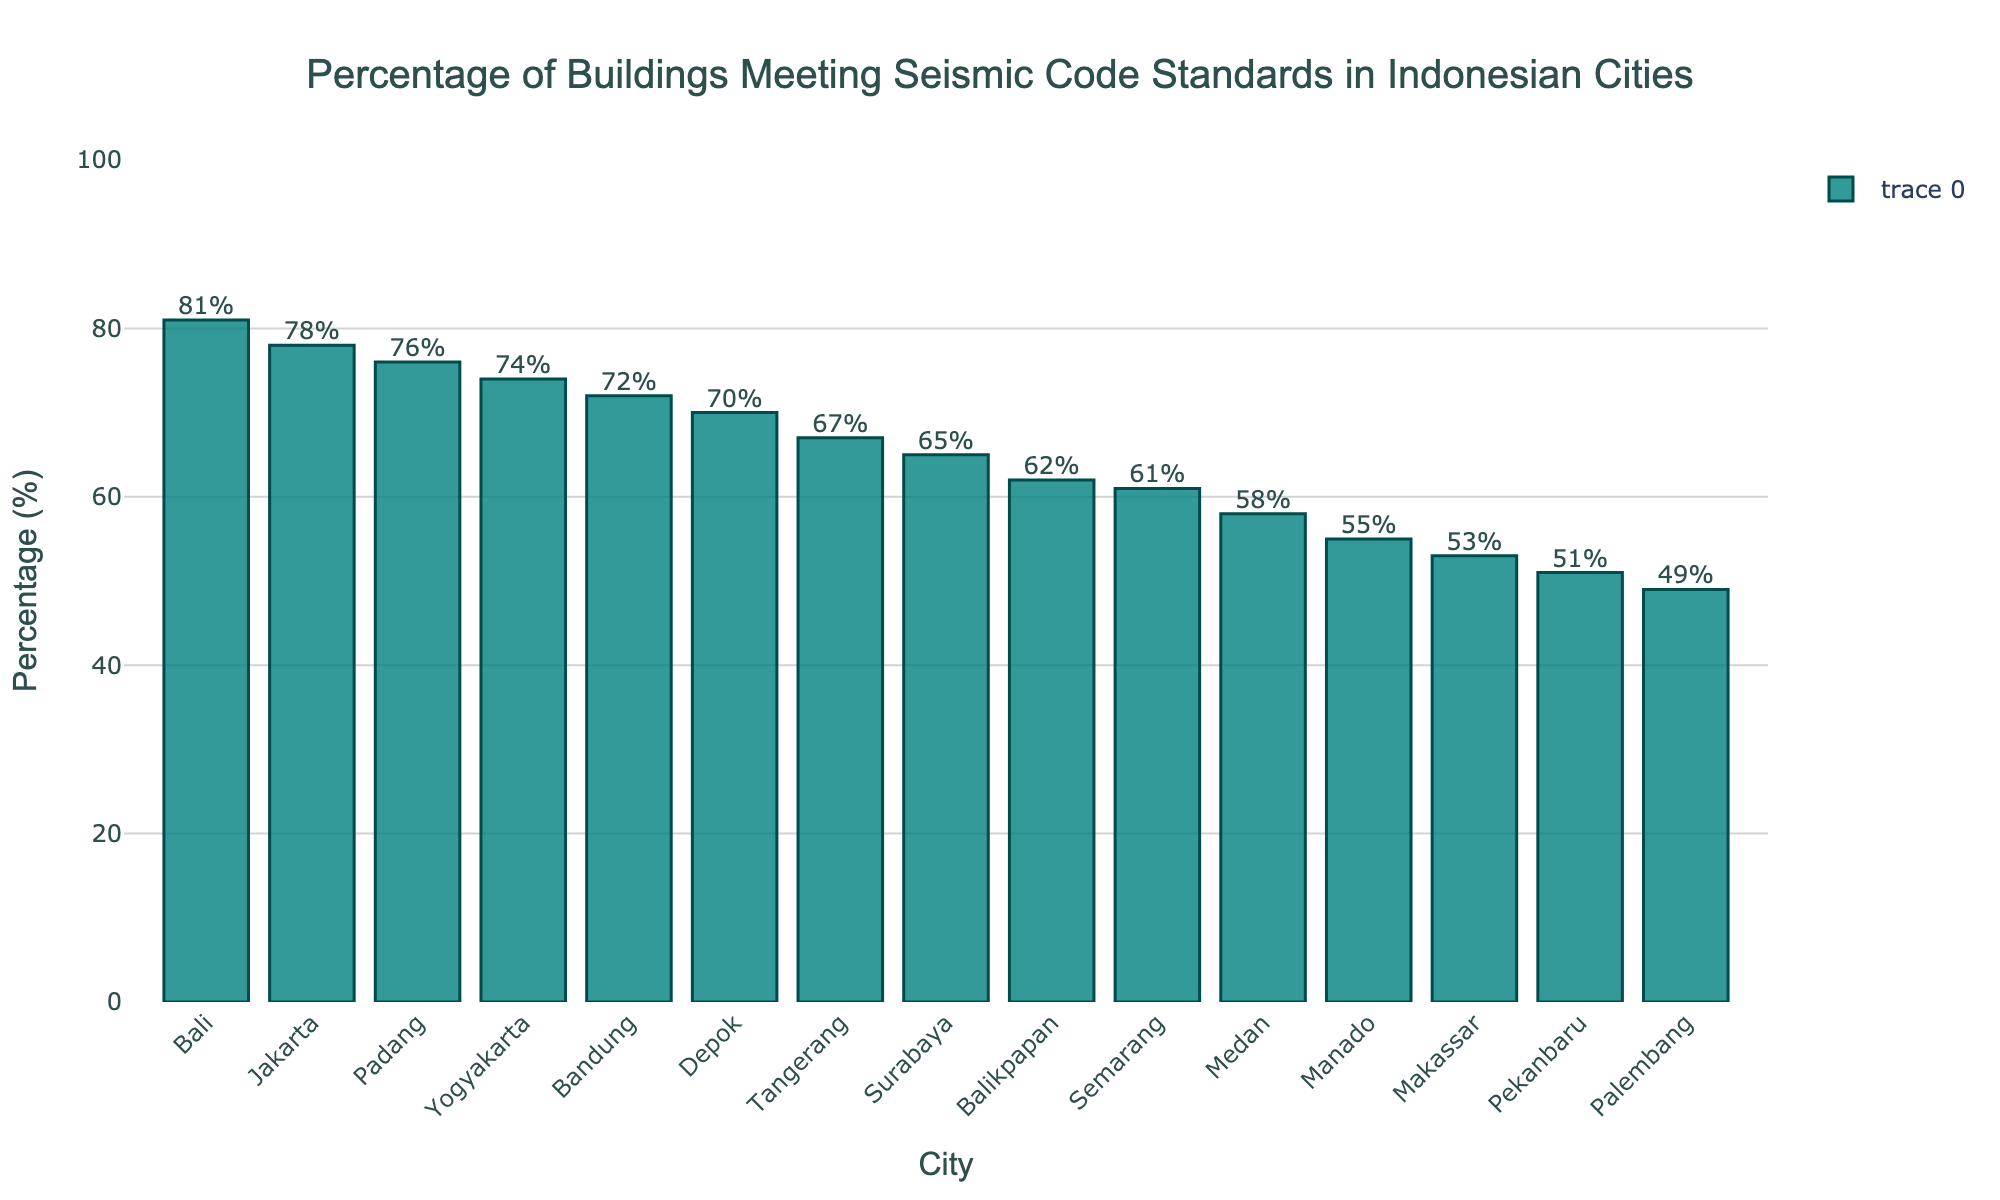What is the percentage of buildings meeting seismic code standards in Jakarta? Locate the bar representing Jakarta and read the value on the y-axis, which is labeled "Percentage (%)". The height of the bar for Jakarta reaches 78%.
Answer: 78% Which city has the lowest percentage of buildings meeting seismic code standards? Identify the shortest bar on the chart, which represents the city with the lowest percentage. The shortest bar corresponds to Palembang with 49%.
Answer: Palembang Between Bandung and Yogyakarta, which city has a higher percentage of buildings meeting seismic code standards? Locate the bars representing Bandung and Yogyakarta, and compare their heights. Bandung has 72% while Yogyakarta has 74%. Yogyakarta has a higher percentage.
Answer: Yogyakarta What is the difference in the percentage of buildings meeting seismic code standards between Surabaya and Makassar? Locate the bars for Surabaya and Makassar, and read their percentages: Surabaya is 65% and Makassar is 53%. Subtract Makassar's percentage from Surabaya's. 65% - 53% = 12%
Answer: 12% What is the average percentage of buildings meeting seismic code standards across all the cities shown? Sum all the percentages and divide by the number of cities. (78 + 65 + 72 + 58 + 61 + 53 + 49 + 67 + 70 + 76 + 81 + 74 + 62 + 55 + 51) / 15 = 64%
Answer: 64% Which city has the highest percentage of buildings meeting seismic code standards? Identify the tallest bar on the chart, which represents the city with the highest percentage. The tallest bar corresponds to Bali with 81%.
Answer: Bali How many cities have a percentage higher than 70%? Count the bars that extend beyond the 70% mark. Jakarta (78%), Bandung (72%), Depok (70%), Padang (76%), Bali (81%), Yogyakarta (74%) result in 6 cities.
Answer: 6 What is the total percentage of buildings meeting seismic code standards for Tanggerang and Manado combined? Locate the bars for Tangerang and Manado and read their percentages: Tangerang is 67% and Manado is 55%. Add these two percentages together. 67% + 55% = 122%
Answer: 122% Which cities have exactly the same percentage of buildings meeting seismic code standards? Inspect the chart to find any bars that are at exactly the same height. None of the bars have the same percentage exactly; all values are unique.
Answer: None 